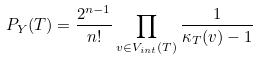Convert formula to latex. <formula><loc_0><loc_0><loc_500><loc_500>P _ { Y } ( T ) = \frac { 2 ^ { n - 1 } } { n ! } \prod _ { v \in V _ { i n t } ( T ) } \frac { 1 } { \kappa _ { T } ( v ) - 1 }</formula> 